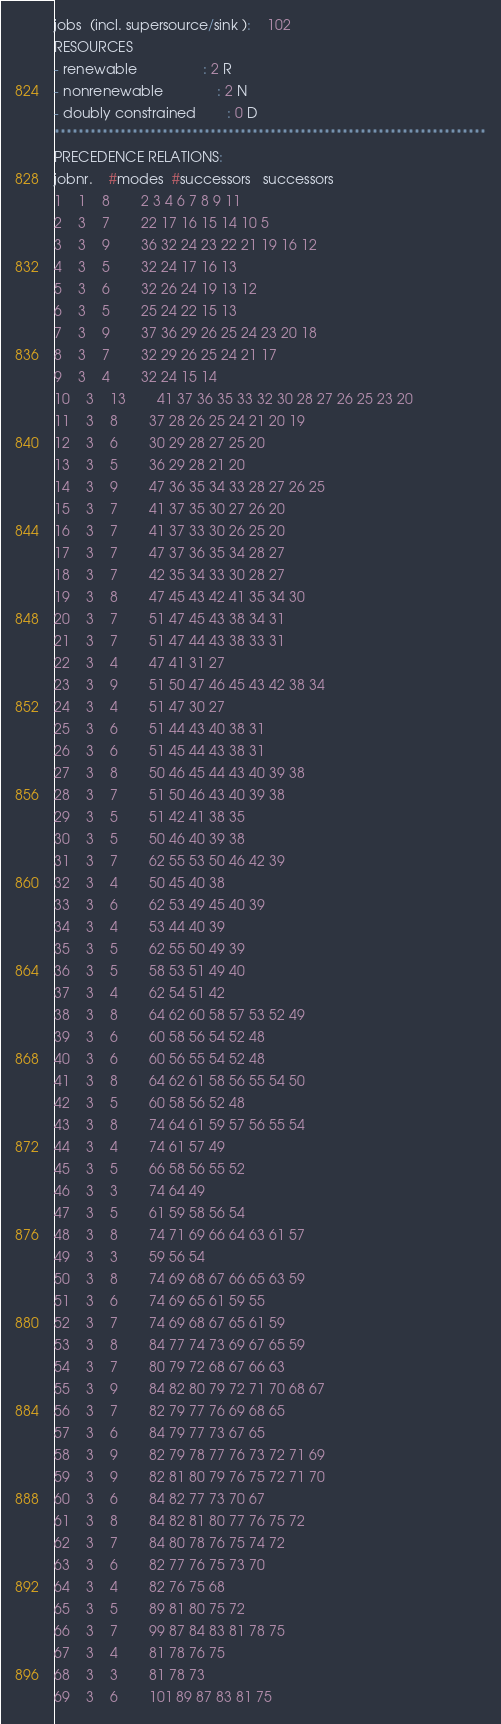Convert code to text. <code><loc_0><loc_0><loc_500><loc_500><_ObjectiveC_>jobs  (incl. supersource/sink ):	102
RESOURCES
- renewable                 : 2 R
- nonrenewable              : 2 N
- doubly constrained        : 0 D
************************************************************************
PRECEDENCE RELATIONS:
jobnr.    #modes  #successors   successors
1	1	8		2 3 4 6 7 8 9 11 
2	3	7		22 17 16 15 14 10 5 
3	3	9		36 32 24 23 22 21 19 16 12 
4	3	5		32 24 17 16 13 
5	3	6		32 26 24 19 13 12 
6	3	5		25 24 22 15 13 
7	3	9		37 36 29 26 25 24 23 20 18 
8	3	7		32 29 26 25 24 21 17 
9	3	4		32 24 15 14 
10	3	13		41 37 36 35 33 32 30 28 27 26 25 23 20 
11	3	8		37 28 26 25 24 21 20 19 
12	3	6		30 29 28 27 25 20 
13	3	5		36 29 28 21 20 
14	3	9		47 36 35 34 33 28 27 26 25 
15	3	7		41 37 35 30 27 26 20 
16	3	7		41 37 33 30 26 25 20 
17	3	7		47 37 36 35 34 28 27 
18	3	7		42 35 34 33 30 28 27 
19	3	8		47 45 43 42 41 35 34 30 
20	3	7		51 47 45 43 38 34 31 
21	3	7		51 47 44 43 38 33 31 
22	3	4		47 41 31 27 
23	3	9		51 50 47 46 45 43 42 38 34 
24	3	4		51 47 30 27 
25	3	6		51 44 43 40 38 31 
26	3	6		51 45 44 43 38 31 
27	3	8		50 46 45 44 43 40 39 38 
28	3	7		51 50 46 43 40 39 38 
29	3	5		51 42 41 38 35 
30	3	5		50 46 40 39 38 
31	3	7		62 55 53 50 46 42 39 
32	3	4		50 45 40 38 
33	3	6		62 53 49 45 40 39 
34	3	4		53 44 40 39 
35	3	5		62 55 50 49 39 
36	3	5		58 53 51 49 40 
37	3	4		62 54 51 42 
38	3	8		64 62 60 58 57 53 52 49 
39	3	6		60 58 56 54 52 48 
40	3	6		60 56 55 54 52 48 
41	3	8		64 62 61 58 56 55 54 50 
42	3	5		60 58 56 52 48 
43	3	8		74 64 61 59 57 56 55 54 
44	3	4		74 61 57 49 
45	3	5		66 58 56 55 52 
46	3	3		74 64 49 
47	3	5		61 59 58 56 54 
48	3	8		74 71 69 66 64 63 61 57 
49	3	3		59 56 54 
50	3	8		74 69 68 67 66 65 63 59 
51	3	6		74 69 65 61 59 55 
52	3	7		74 69 68 67 65 61 59 
53	3	8		84 77 74 73 69 67 65 59 
54	3	7		80 79 72 68 67 66 63 
55	3	9		84 82 80 79 72 71 70 68 67 
56	3	7		82 79 77 76 69 68 65 
57	3	6		84 79 77 73 67 65 
58	3	9		82 79 78 77 76 73 72 71 69 
59	3	9		82 81 80 79 76 75 72 71 70 
60	3	6		84 82 77 73 70 67 
61	3	8		84 82 81 80 77 76 75 72 
62	3	7		84 80 78 76 75 74 72 
63	3	6		82 77 76 75 73 70 
64	3	4		82 76 75 68 
65	3	5		89 81 80 75 72 
66	3	7		99 87 84 83 81 78 75 
67	3	4		81 78 76 75 
68	3	3		81 78 73 
69	3	6		101 89 87 83 81 75 </code> 